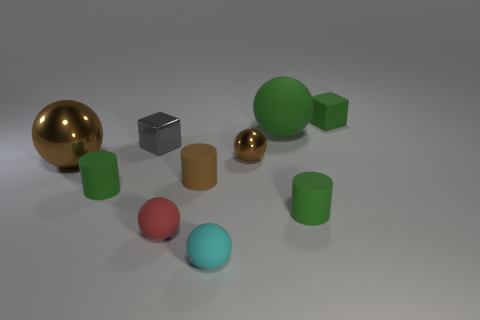What number of other objects are there of the same size as the red sphere?
Make the answer very short. 7. There is another thing that is the same shape as the tiny gray thing; what is it made of?
Ensure brevity in your answer.  Rubber. What material is the green thing that is to the left of the tiny sphere that is behind the small matte ball that is behind the cyan matte object?
Your answer should be very brief. Rubber. What is the size of the green sphere that is made of the same material as the cyan thing?
Provide a short and direct response. Large. Is there anything else that is the same color as the big rubber object?
Ensure brevity in your answer.  Yes. There is a big sphere behind the big shiny thing; is its color the same as the small matte cube that is right of the small brown metal thing?
Your answer should be compact. Yes. What is the color of the small rubber cylinder that is to the right of the green rubber ball?
Make the answer very short. Green. Is the size of the green cylinder that is on the left side of the red matte thing the same as the big brown metal sphere?
Give a very brief answer. No. Is the number of tiny brown rubber cylinders less than the number of big cyan metal cylinders?
Keep it short and to the point. No. The metallic thing that is the same color as the small shiny ball is what shape?
Offer a very short reply. Sphere. 